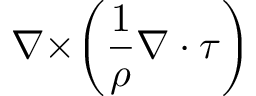Convert formula to latex. <formula><loc_0><loc_0><loc_500><loc_500>\nabla \times \left ( \frac { 1 } { \rho } \nabla \cdot \tau \right )</formula> 